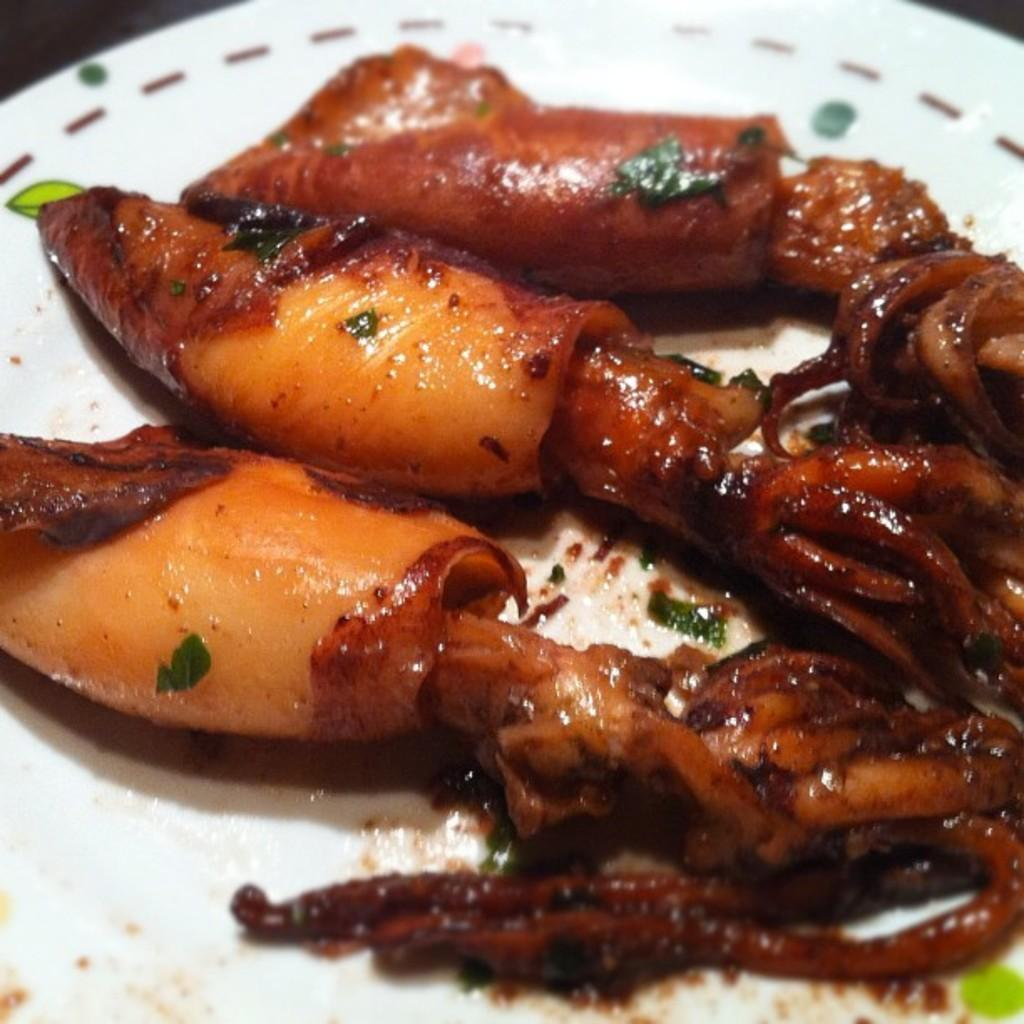What object is present in the image that is typically used for serving food? There is a plate in the image. What is on the plate in the image? The plate is served with food. What type of gun is visible on the plate in the image? There is no gun present on the plate or in the image. What phase of the moon can be seen in the image? The image does not show the moon or any celestial bodies; it only features a plate with food. 